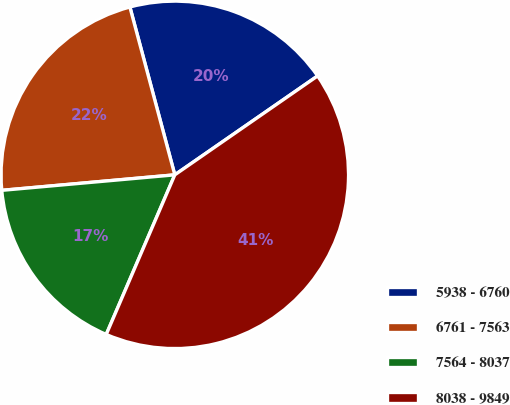Convert chart to OTSL. <chart><loc_0><loc_0><loc_500><loc_500><pie_chart><fcel>5938 - 6760<fcel>6761 - 7563<fcel>7564 - 8037<fcel>8038 - 9849<nl><fcel>19.52%<fcel>22.26%<fcel>17.12%<fcel>41.1%<nl></chart> 